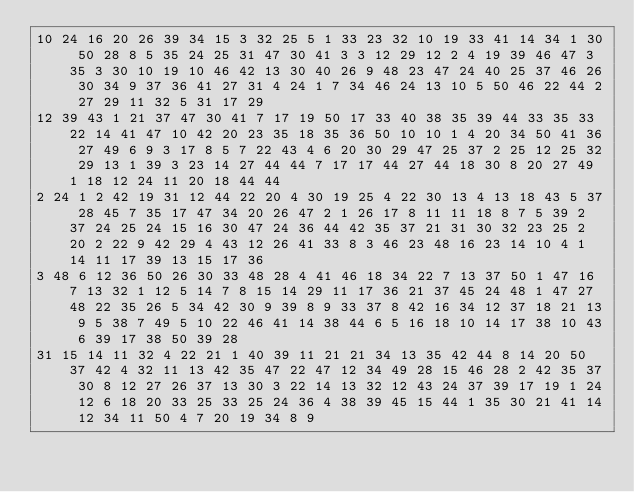<code> <loc_0><loc_0><loc_500><loc_500><_Matlab_>10 24 16 20 26 39 34 15 3 32 25 5 1 33 23 32 10 19 33 41 14 34 1 30 50 28 8 5 35 24 25 31 47 30 41 3 3 12 29 12 2 4 19 39 46 47 3 35 3 30 10 19 10 46 42 13 30 40 26 9 48 23 47 24 40 25 37 46 26 30 34 9 37 36 41 27 31 4 24 1 7 34 46 24 13 10 5 50 46 22 44 2 27 29 11 32 5 31 17 29
12 39 43 1 21 37 47 30 41 7 17 19 50 17 33 40 38 35 39 44 33 35 33 22 14 41 47 10 42 20 23 35 18 35 36 50 10 10 1 4 20 34 50 41 36 27 49 6 9 3 17 8 5 7 22 43 4 6 20 30 29 47 25 37 2 25 12 25 32 29 13 1 39 3 23 14 27 44 44 7 17 17 44 27 44 18 30 8 20 27 49 1 18 12 24 11 20 18 44 44
2 24 1 2 42 19 31 12 44 22 20 4 30 19 25 4 22 30 13 4 13 18 43 5 37 28 45 7 35 17 47 34 20 26 47 2 1 26 17 8 11 11 18 8 7 5 39 2 37 24 25 24 15 16 30 47 24 36 44 42 35 37 21 31 30 32 23 25 2 20 2 22 9 42 29 4 43 12 26 41 33 8 3 46 23 48 16 23 14 10 4 1 14 11 17 39 13 15 17 36
3 48 6 12 36 50 26 30 33 48 28 4 41 46 18 34 22 7 13 37 50 1 47 16 7 13 32 1 12 5 14 7 8 15 14 29 11 17 36 21 37 45 24 48 1 47 27 48 22 35 26 5 34 42 30 9 39 8 9 33 37 8 42 16 34 12 37 18 21 13 9 5 38 7 49 5 10 22 46 41 14 38 44 6 5 16 18 10 14 17 38 10 43 6 39 17 38 50 39 28
31 15 14 11 32 4 22 21 1 40 39 11 21 21 34 13 35 42 44 8 14 20 50 37 42 4 32 11 13 42 35 47 22 47 12 34 49 28 15 46 28 2 42 35 37 30 8 12 27 26 37 13 30 3 22 14 13 32 12 43 24 37 39 17 19 1 24 12 6 18 20 33 25 33 25 24 36 4 38 39 45 15 44 1 35 30 21 41 14 12 34 11 50 4 7 20 19 34 8 9</code> 